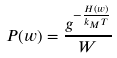<formula> <loc_0><loc_0><loc_500><loc_500>P ( w ) = \frac { g ^ { - \frac { H ( w ) } { k _ { M } T } } } { W }</formula> 